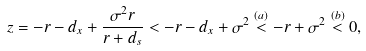Convert formula to latex. <formula><loc_0><loc_0><loc_500><loc_500>z = - r - d _ { x } + \frac { \sigma ^ { 2 } r } { r + d _ { s } } < - r - d _ { x } + \sigma ^ { 2 } \stackrel { ( a ) } { < } - r + \sigma ^ { 2 } \stackrel { ( b ) } { < } 0 ,</formula> 